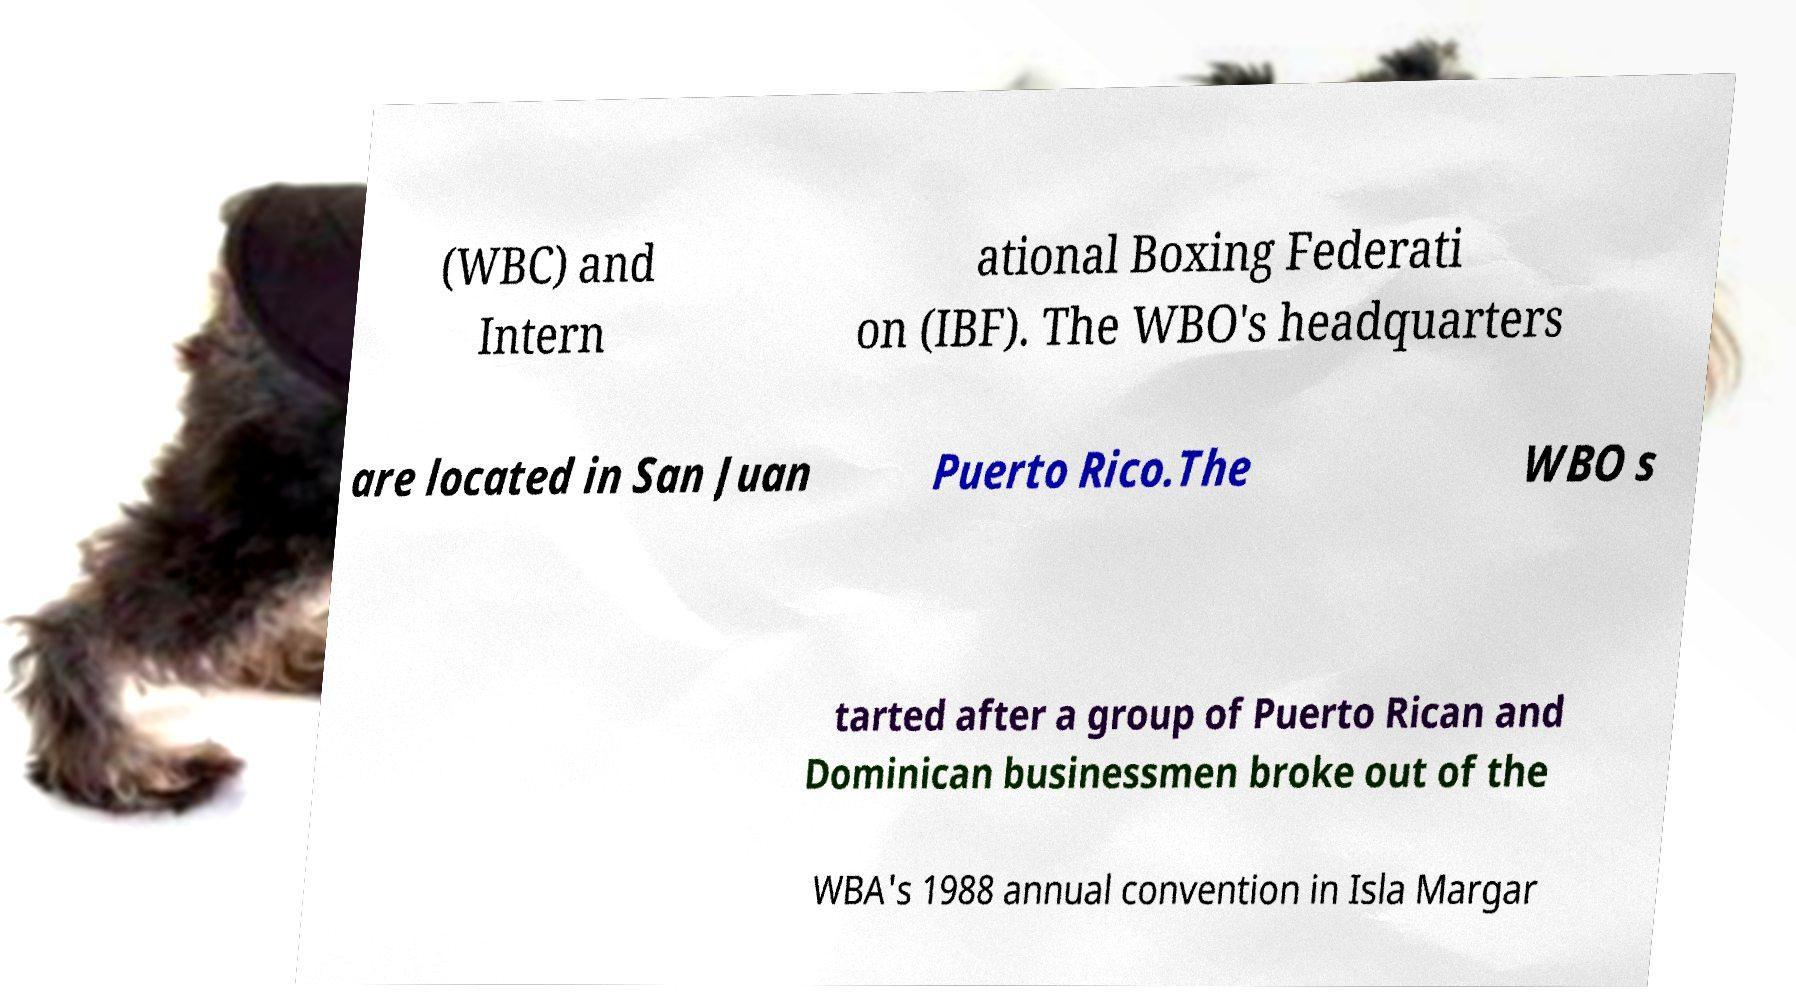There's text embedded in this image that I need extracted. Can you transcribe it verbatim? (WBC) and Intern ational Boxing Federati on (IBF). The WBO's headquarters are located in San Juan Puerto Rico.The WBO s tarted after a group of Puerto Rican and Dominican businessmen broke out of the WBA's 1988 annual convention in Isla Margar 